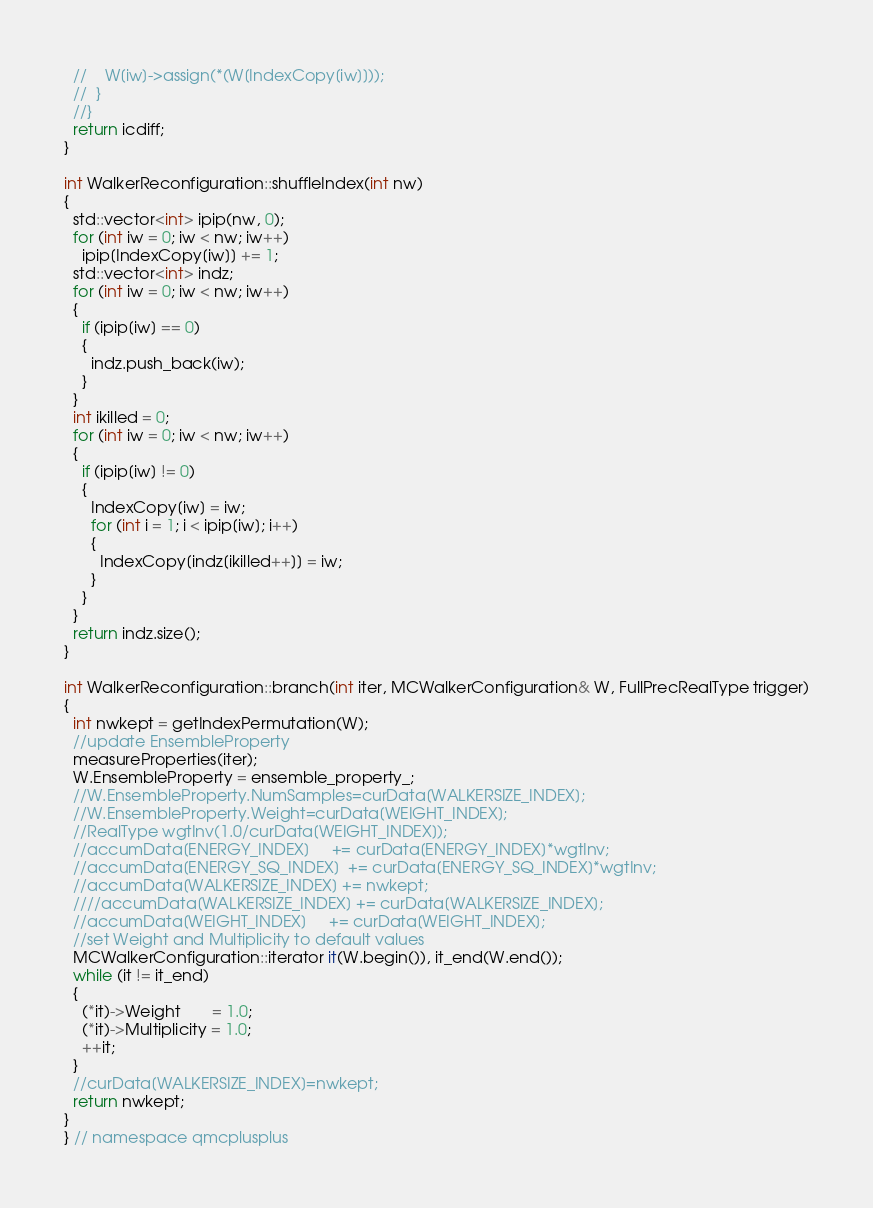Convert code to text. <code><loc_0><loc_0><loc_500><loc_500><_C++_>  //    W[iw]->assign(*(W[IndexCopy[iw]]));
  //  }
  //}
  return icdiff;
}

int WalkerReconfiguration::shuffleIndex(int nw)
{
  std::vector<int> ipip(nw, 0);
  for (int iw = 0; iw < nw; iw++)
    ipip[IndexCopy[iw]] += 1;
  std::vector<int> indz;
  for (int iw = 0; iw < nw; iw++)
  {
    if (ipip[iw] == 0)
    {
      indz.push_back(iw);
    }
  }
  int ikilled = 0;
  for (int iw = 0; iw < nw; iw++)
  {
    if (ipip[iw] != 0)
    {
      IndexCopy[iw] = iw;
      for (int i = 1; i < ipip[iw]; i++)
      {
        IndexCopy[indz[ikilled++]] = iw;
      }
    }
  }
  return indz.size();
}

int WalkerReconfiguration::branch(int iter, MCWalkerConfiguration& W, FullPrecRealType trigger)
{
  int nwkept = getIndexPermutation(W);
  //update EnsembleProperty
  measureProperties(iter);
  W.EnsembleProperty = ensemble_property_;
  //W.EnsembleProperty.NumSamples=curData[WALKERSIZE_INDEX];
  //W.EnsembleProperty.Weight=curData[WEIGHT_INDEX];
  //RealType wgtInv(1.0/curData[WEIGHT_INDEX]);
  //accumData[ENERGY_INDEX]     += curData[ENERGY_INDEX]*wgtInv;
  //accumData[ENERGY_SQ_INDEX]  += curData[ENERGY_SQ_INDEX]*wgtInv;
  //accumData[WALKERSIZE_INDEX] += nwkept;
  ////accumData[WALKERSIZE_INDEX] += curData[WALKERSIZE_INDEX];
  //accumData[WEIGHT_INDEX]     += curData[WEIGHT_INDEX];
  //set Weight and Multiplicity to default values
  MCWalkerConfiguration::iterator it(W.begin()), it_end(W.end());
  while (it != it_end)
  {
    (*it)->Weight       = 1.0;
    (*it)->Multiplicity = 1.0;
    ++it;
  }
  //curData[WALKERSIZE_INDEX]=nwkept;
  return nwkept;
}
} // namespace qmcplusplus
</code> 